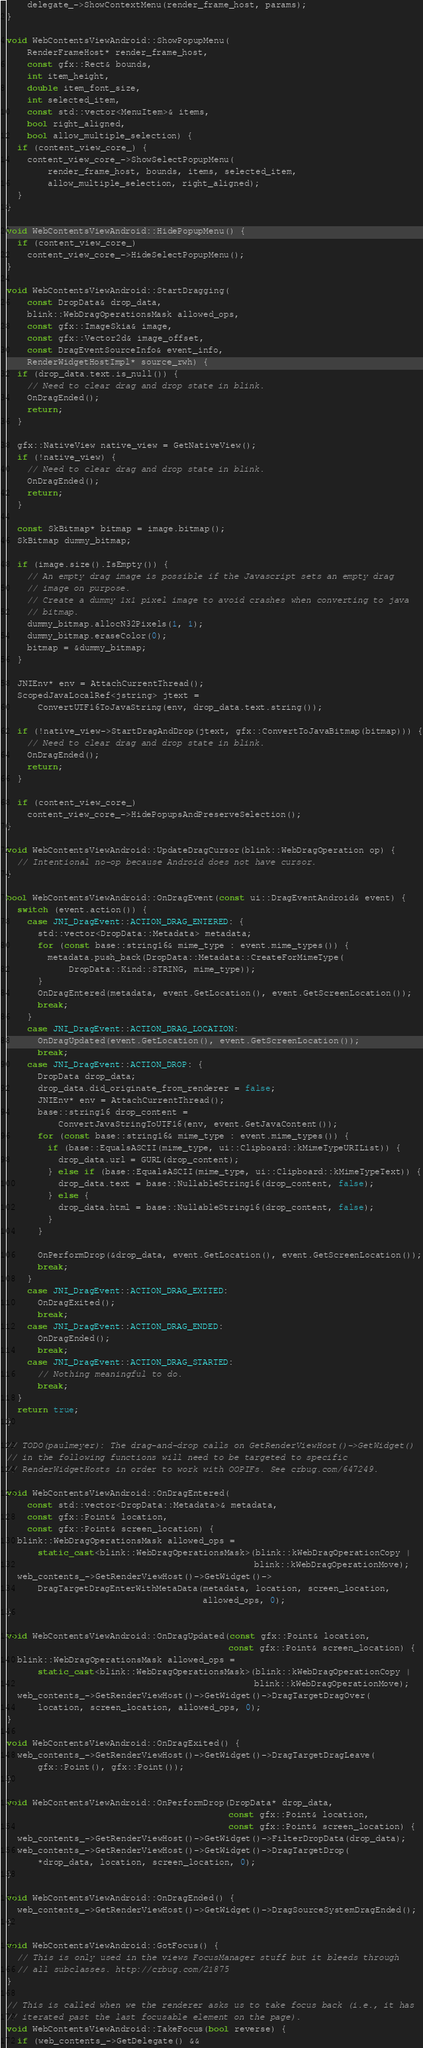Convert code to text. <code><loc_0><loc_0><loc_500><loc_500><_C++_>    delegate_->ShowContextMenu(render_frame_host, params);
}

void WebContentsViewAndroid::ShowPopupMenu(
    RenderFrameHost* render_frame_host,
    const gfx::Rect& bounds,
    int item_height,
    double item_font_size,
    int selected_item,
    const std::vector<MenuItem>& items,
    bool right_aligned,
    bool allow_multiple_selection) {
  if (content_view_core_) {
    content_view_core_->ShowSelectPopupMenu(
        render_frame_host, bounds, items, selected_item,
        allow_multiple_selection, right_aligned);
  }
}

void WebContentsViewAndroid::HidePopupMenu() {
  if (content_view_core_)
    content_view_core_->HideSelectPopupMenu();
}

void WebContentsViewAndroid::StartDragging(
    const DropData& drop_data,
    blink::WebDragOperationsMask allowed_ops,
    const gfx::ImageSkia& image,
    const gfx::Vector2d& image_offset,
    const DragEventSourceInfo& event_info,
    RenderWidgetHostImpl* source_rwh) {
  if (drop_data.text.is_null()) {
    // Need to clear drag and drop state in blink.
    OnDragEnded();
    return;
  }

  gfx::NativeView native_view = GetNativeView();
  if (!native_view) {
    // Need to clear drag and drop state in blink.
    OnDragEnded();
    return;
  }

  const SkBitmap* bitmap = image.bitmap();
  SkBitmap dummy_bitmap;

  if (image.size().IsEmpty()) {
    // An empty drag image is possible if the Javascript sets an empty drag
    // image on purpose.
    // Create a dummy 1x1 pixel image to avoid crashes when converting to java
    // bitmap.
    dummy_bitmap.allocN32Pixels(1, 1);
    dummy_bitmap.eraseColor(0);
    bitmap = &dummy_bitmap;
  }

  JNIEnv* env = AttachCurrentThread();
  ScopedJavaLocalRef<jstring> jtext =
      ConvertUTF16ToJavaString(env, drop_data.text.string());

  if (!native_view->StartDragAndDrop(jtext, gfx::ConvertToJavaBitmap(bitmap))) {
    // Need to clear drag and drop state in blink.
    OnDragEnded();
    return;
  }

  if (content_view_core_)
    content_view_core_->HidePopupsAndPreserveSelection();
}

void WebContentsViewAndroid::UpdateDragCursor(blink::WebDragOperation op) {
  // Intentional no-op because Android does not have cursor.
}

bool WebContentsViewAndroid::OnDragEvent(const ui::DragEventAndroid& event) {
  switch (event.action()) {
    case JNI_DragEvent::ACTION_DRAG_ENTERED: {
      std::vector<DropData::Metadata> metadata;
      for (const base::string16& mime_type : event.mime_types()) {
        metadata.push_back(DropData::Metadata::CreateForMimeType(
            DropData::Kind::STRING, mime_type));
      }
      OnDragEntered(metadata, event.GetLocation(), event.GetScreenLocation());
      break;
    }
    case JNI_DragEvent::ACTION_DRAG_LOCATION:
      OnDragUpdated(event.GetLocation(), event.GetScreenLocation());
      break;
    case JNI_DragEvent::ACTION_DROP: {
      DropData drop_data;
      drop_data.did_originate_from_renderer = false;
      JNIEnv* env = AttachCurrentThread();
      base::string16 drop_content =
          ConvertJavaStringToUTF16(env, event.GetJavaContent());
      for (const base::string16& mime_type : event.mime_types()) {
        if (base::EqualsASCII(mime_type, ui::Clipboard::kMimeTypeURIList)) {
          drop_data.url = GURL(drop_content);
        } else if (base::EqualsASCII(mime_type, ui::Clipboard::kMimeTypeText)) {
          drop_data.text = base::NullableString16(drop_content, false);
        } else {
          drop_data.html = base::NullableString16(drop_content, false);
        }
      }

      OnPerformDrop(&drop_data, event.GetLocation(), event.GetScreenLocation());
      break;
    }
    case JNI_DragEvent::ACTION_DRAG_EXITED:
      OnDragExited();
      break;
    case JNI_DragEvent::ACTION_DRAG_ENDED:
      OnDragEnded();
      break;
    case JNI_DragEvent::ACTION_DRAG_STARTED:
      // Nothing meaningful to do.
      break;
  }
  return true;
}

// TODO(paulmeyer): The drag-and-drop calls on GetRenderViewHost()->GetWidget()
// in the following functions will need to be targeted to specific
// RenderWidgetHosts in order to work with OOPIFs. See crbug.com/647249.

void WebContentsViewAndroid::OnDragEntered(
    const std::vector<DropData::Metadata>& metadata,
    const gfx::Point& location,
    const gfx::Point& screen_location) {
  blink::WebDragOperationsMask allowed_ops =
      static_cast<blink::WebDragOperationsMask>(blink::kWebDragOperationCopy |
                                                blink::kWebDragOperationMove);
  web_contents_->GetRenderViewHost()->GetWidget()->
      DragTargetDragEnterWithMetaData(metadata, location, screen_location,
                                      allowed_ops, 0);
}

void WebContentsViewAndroid::OnDragUpdated(const gfx::Point& location,
                                           const gfx::Point& screen_location) {
  blink::WebDragOperationsMask allowed_ops =
      static_cast<blink::WebDragOperationsMask>(blink::kWebDragOperationCopy |
                                                blink::kWebDragOperationMove);
  web_contents_->GetRenderViewHost()->GetWidget()->DragTargetDragOver(
      location, screen_location, allowed_ops, 0);
}

void WebContentsViewAndroid::OnDragExited() {
  web_contents_->GetRenderViewHost()->GetWidget()->DragTargetDragLeave(
      gfx::Point(), gfx::Point());
}

void WebContentsViewAndroid::OnPerformDrop(DropData* drop_data,
                                           const gfx::Point& location,
                                           const gfx::Point& screen_location) {
  web_contents_->GetRenderViewHost()->GetWidget()->FilterDropData(drop_data);
  web_contents_->GetRenderViewHost()->GetWidget()->DragTargetDrop(
      *drop_data, location, screen_location, 0);
}

void WebContentsViewAndroid::OnDragEnded() {
  web_contents_->GetRenderViewHost()->GetWidget()->DragSourceSystemDragEnded();
}

void WebContentsViewAndroid::GotFocus() {
  // This is only used in the views FocusManager stuff but it bleeds through
  // all subclasses. http://crbug.com/21875
}

// This is called when we the renderer asks us to take focus back (i.e., it has
// iterated past the last focusable element on the page).
void WebContentsViewAndroid::TakeFocus(bool reverse) {
  if (web_contents_->GetDelegate() &&</code> 